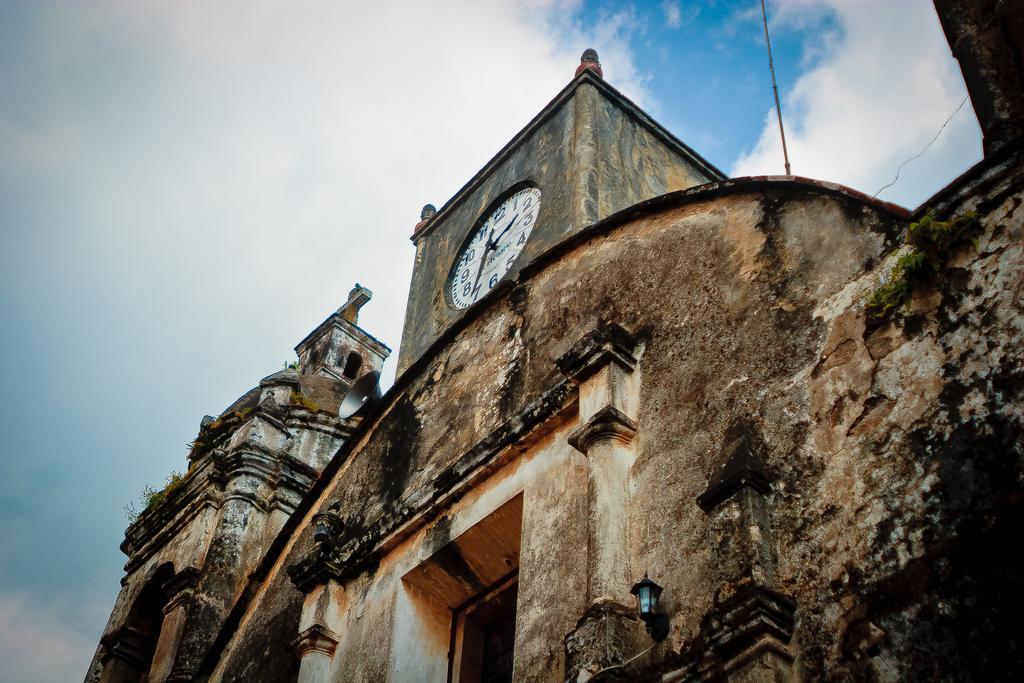Could you give a brief overview of what you see in this image? In this picture there is a clock tower. At bottom there is a door and we can see a monument. At the top we can see sky and clouds. 